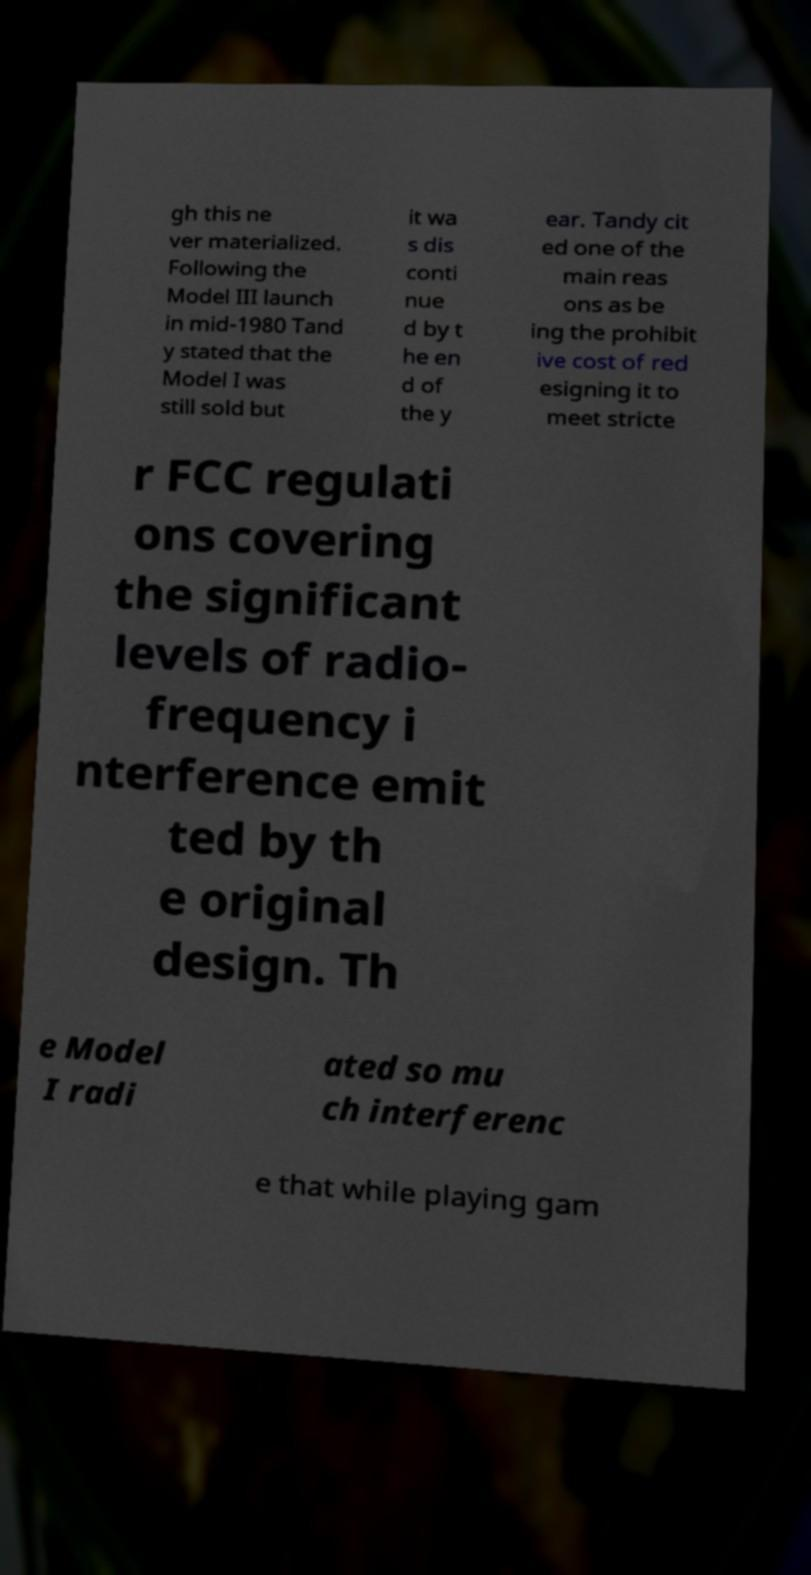Could you extract and type out the text from this image? gh this ne ver materialized. Following the Model III launch in mid-1980 Tand y stated that the Model I was still sold but it wa s dis conti nue d by t he en d of the y ear. Tandy cit ed one of the main reas ons as be ing the prohibit ive cost of red esigning it to meet stricte r FCC regulati ons covering the significant levels of radio- frequency i nterference emit ted by th e original design. Th e Model I radi ated so mu ch interferenc e that while playing gam 